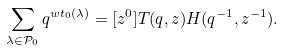<formula> <loc_0><loc_0><loc_500><loc_500>\sum _ { \lambda \in \mathcal { P } _ { 0 } } q ^ { w t _ { 0 } ( \lambda ) } = [ z ^ { 0 } ] T ( q , z ) H ( q ^ { - 1 } , z ^ { - 1 } ) .</formula> 